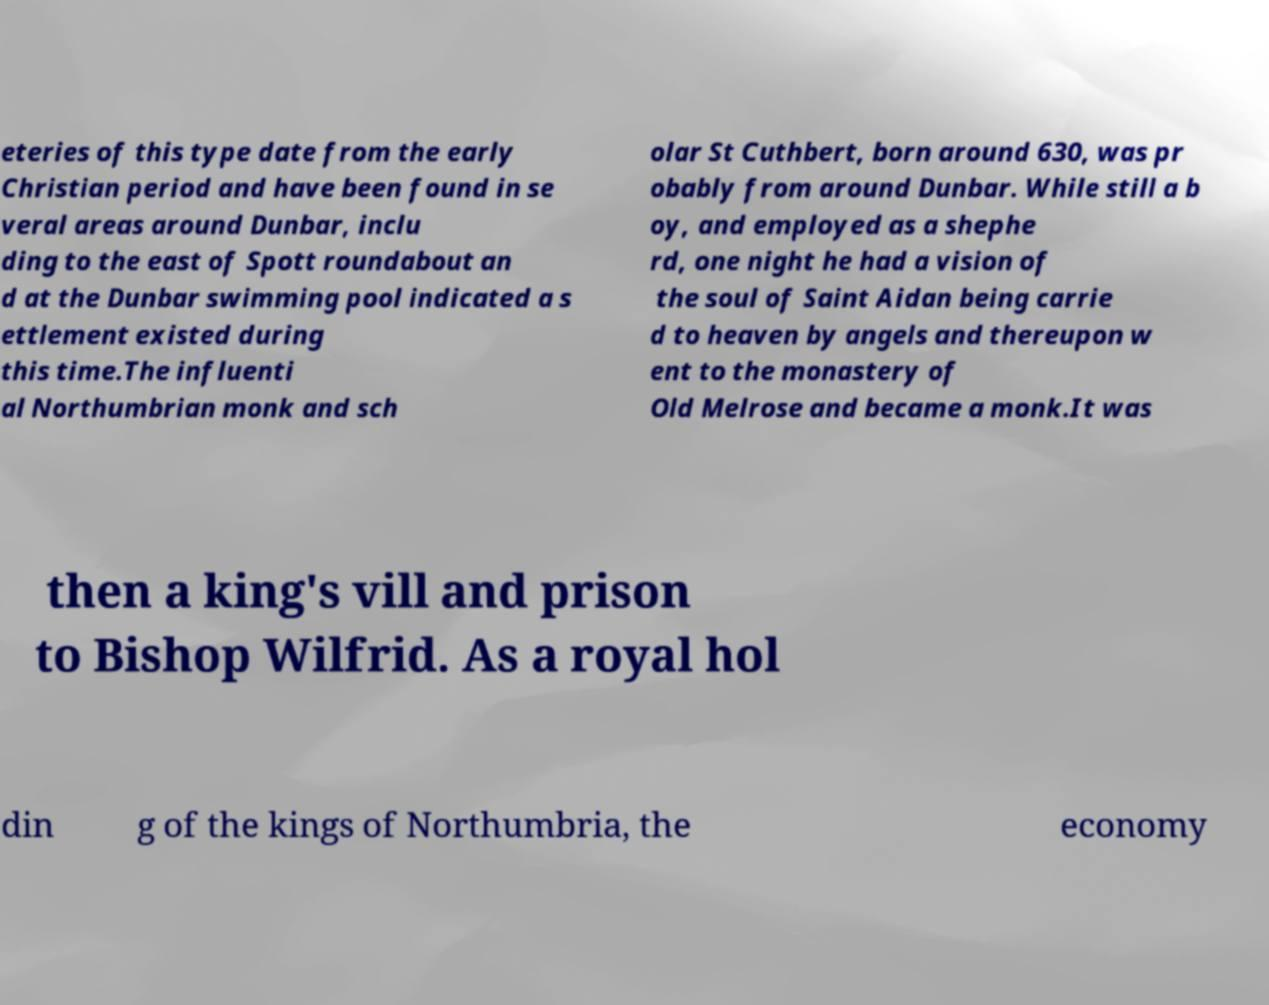I need the written content from this picture converted into text. Can you do that? eteries of this type date from the early Christian period and have been found in se veral areas around Dunbar, inclu ding to the east of Spott roundabout an d at the Dunbar swimming pool indicated a s ettlement existed during this time.The influenti al Northumbrian monk and sch olar St Cuthbert, born around 630, was pr obably from around Dunbar. While still a b oy, and employed as a shephe rd, one night he had a vision of the soul of Saint Aidan being carrie d to heaven by angels and thereupon w ent to the monastery of Old Melrose and became a monk.It was then a king's vill and prison to Bishop Wilfrid. As a royal hol din g of the kings of Northumbria, the economy 